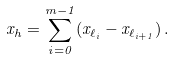Convert formula to latex. <formula><loc_0><loc_0><loc_500><loc_500>x _ { h } = \sum _ { i = 0 } ^ { m - 1 } ( x _ { \ell _ { i } } - x _ { \ell _ { i + 1 } } ) \, .</formula> 